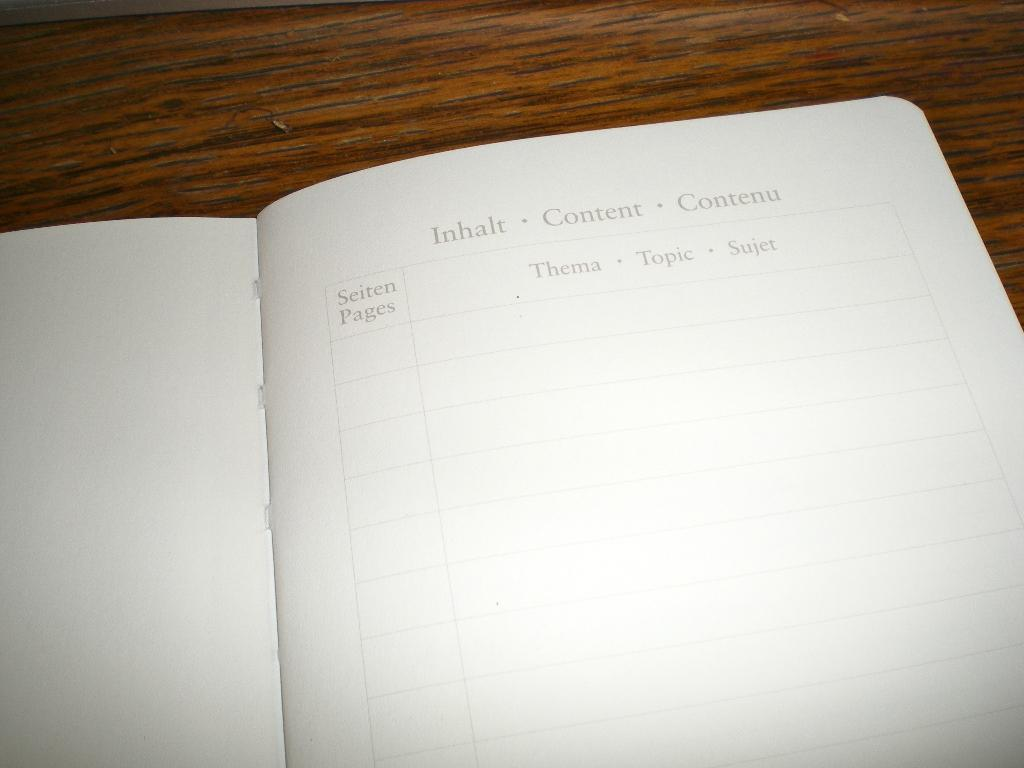<image>
Render a clear and concise summary of the photo. the word content is on the front page 